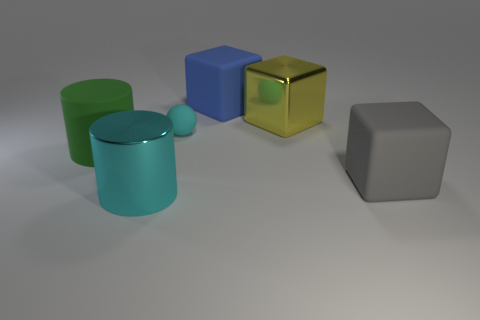Subtract all big rubber cubes. How many cubes are left? 1 Subtract 1 cubes. How many cubes are left? 2 Add 4 big yellow things. How many objects exist? 10 Add 1 big blue shiny cylinders. How many big blue shiny cylinders exist? 1 Subtract 0 gray spheres. How many objects are left? 6 Subtract all cylinders. How many objects are left? 4 Subtract all purple cubes. Subtract all yellow cylinders. How many cubes are left? 3 Subtract all big brown rubber objects. Subtract all cyan shiny things. How many objects are left? 5 Add 2 small cyan things. How many small cyan things are left? 3 